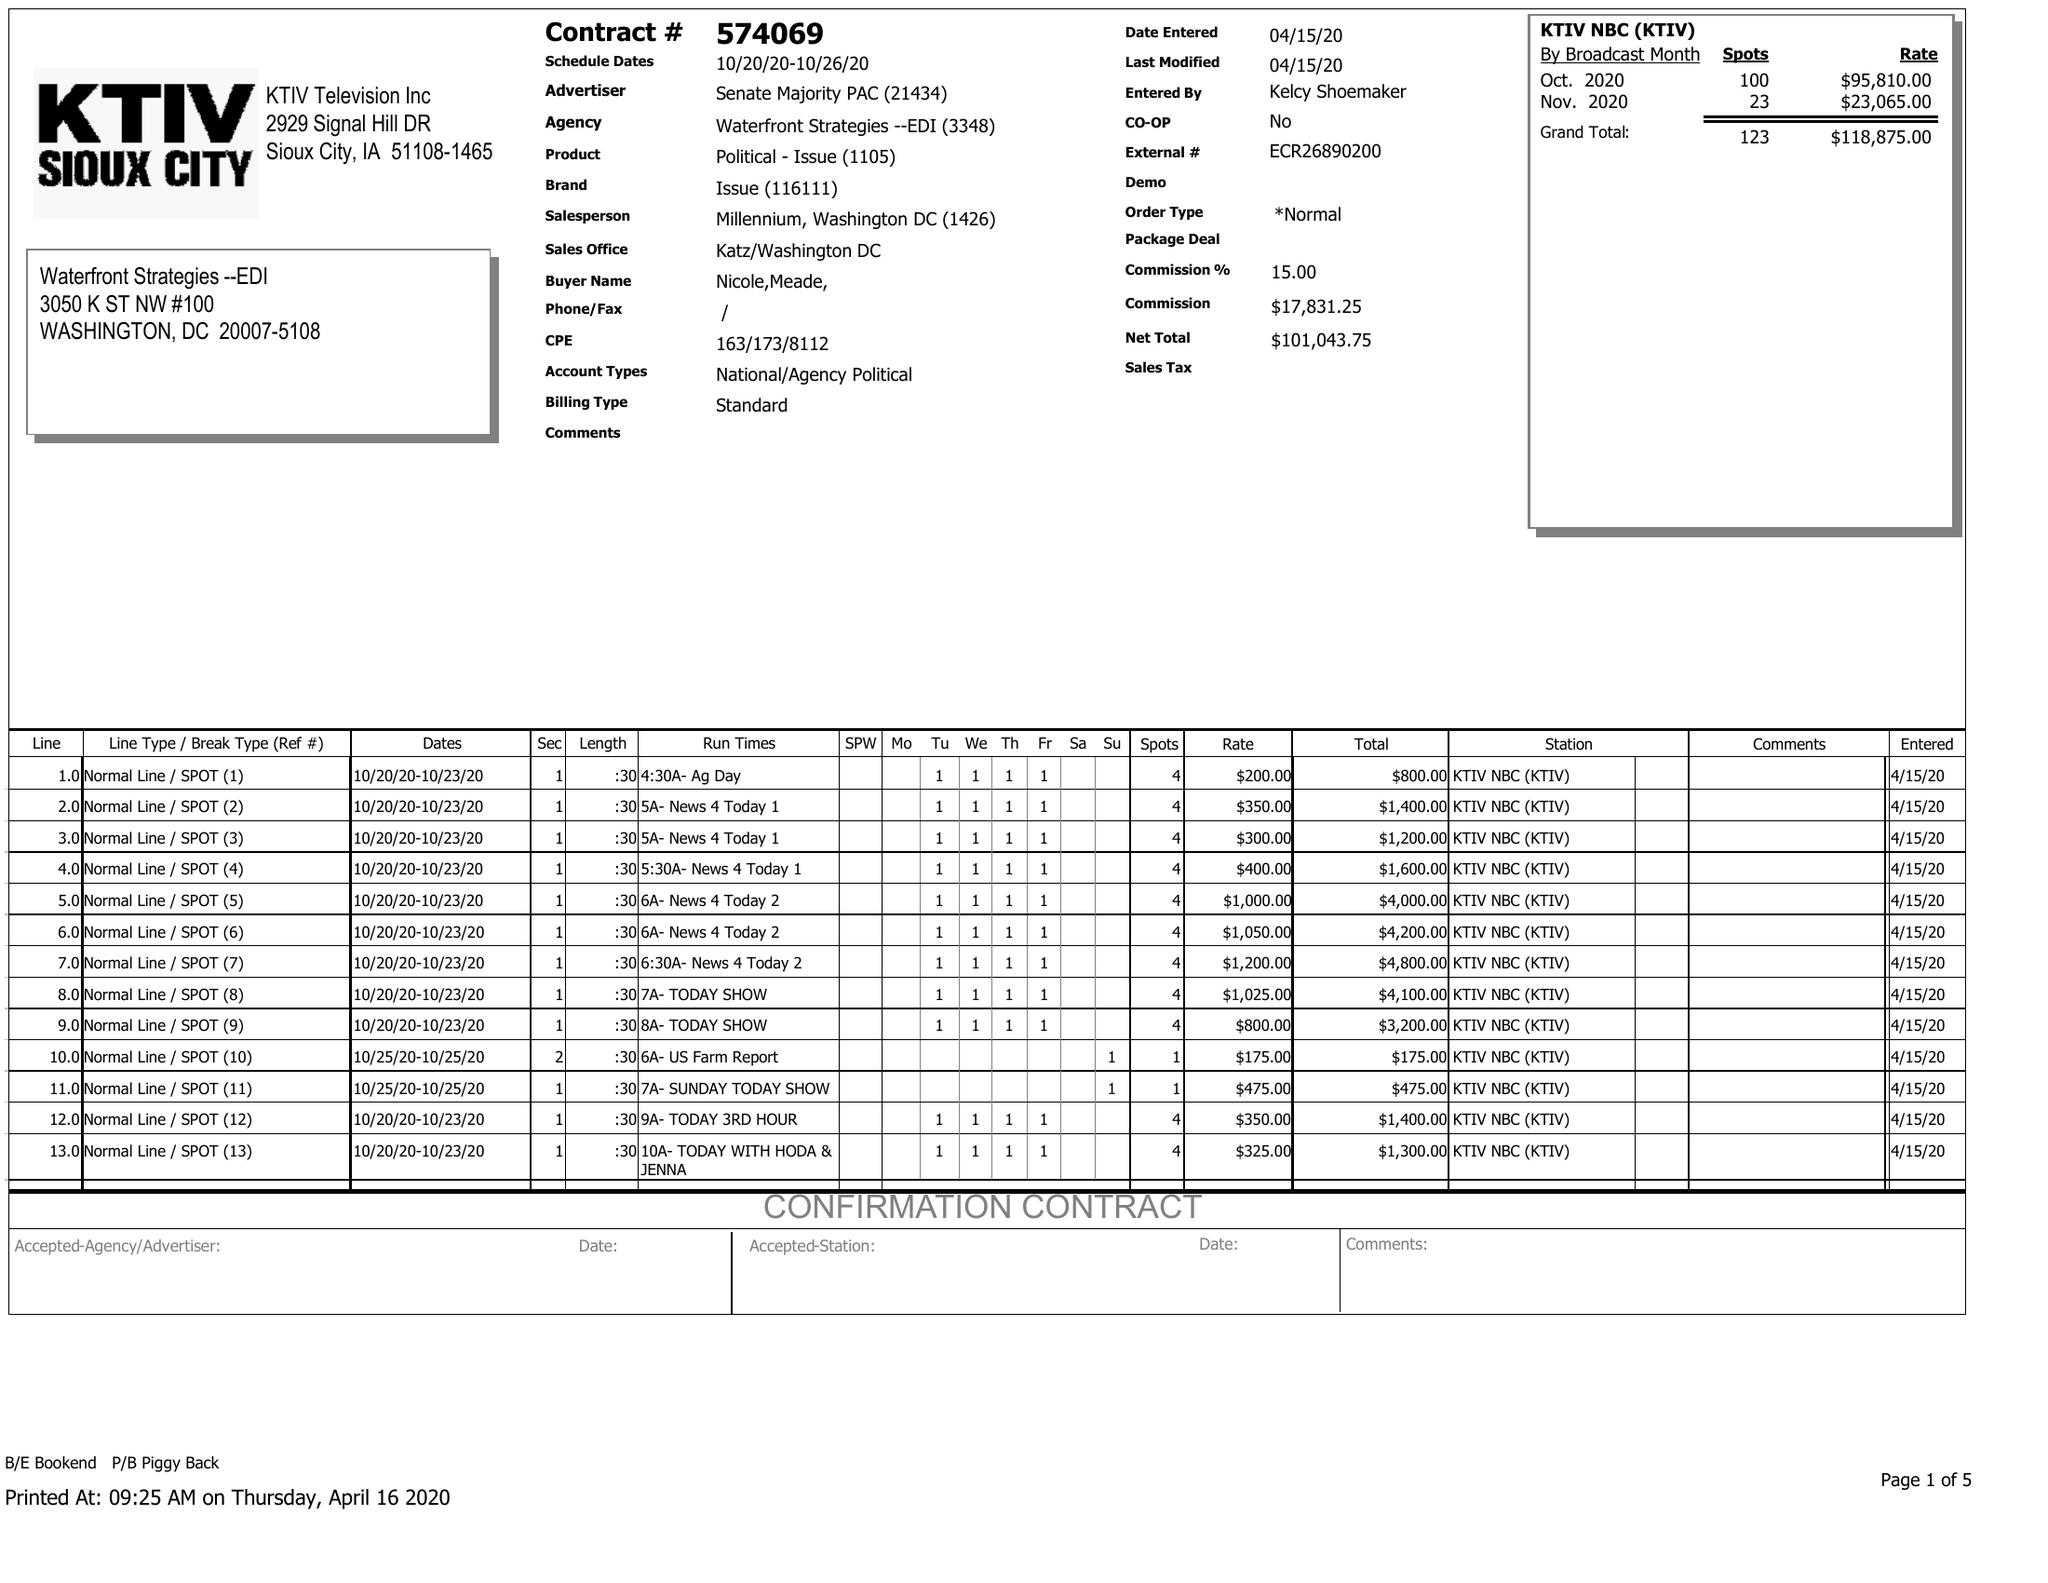What is the value for the advertiser?
Answer the question using a single word or phrase. SENATE MAJORITY PAC 